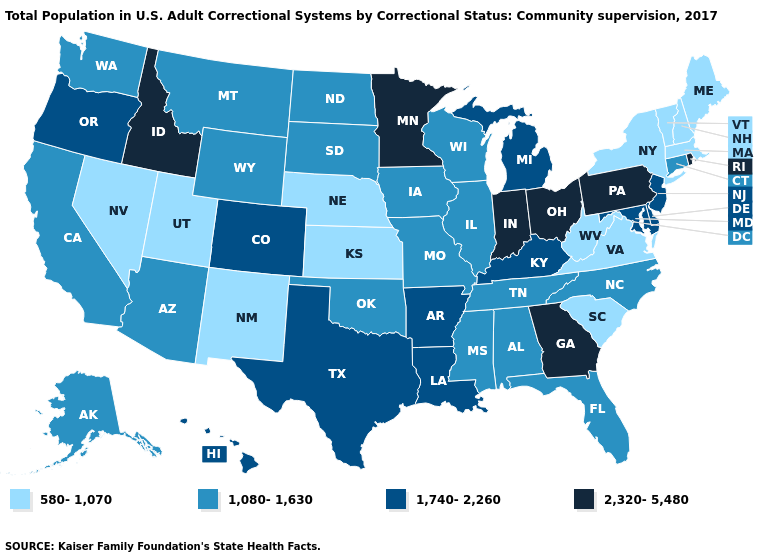Does the first symbol in the legend represent the smallest category?
Quick response, please. Yes. Among the states that border Kentucky , which have the highest value?
Quick response, please. Indiana, Ohio. What is the lowest value in states that border Kansas?
Write a very short answer. 580-1,070. Among the states that border Delaware , does Pennsylvania have the lowest value?
Be succinct. No. What is the highest value in the Northeast ?
Give a very brief answer. 2,320-5,480. Does Washington have a lower value than North Dakota?
Be succinct. No. What is the value of Illinois?
Answer briefly. 1,080-1,630. What is the value of Kansas?
Concise answer only. 580-1,070. Name the states that have a value in the range 1,080-1,630?
Write a very short answer. Alabama, Alaska, Arizona, California, Connecticut, Florida, Illinois, Iowa, Mississippi, Missouri, Montana, North Carolina, North Dakota, Oklahoma, South Dakota, Tennessee, Washington, Wisconsin, Wyoming. What is the highest value in the USA?
Short answer required. 2,320-5,480. What is the value of Pennsylvania?
Quick response, please. 2,320-5,480. Does Idaho have the highest value in the USA?
Write a very short answer. Yes. Does North Carolina have the highest value in the South?
Give a very brief answer. No. What is the value of Rhode Island?
Write a very short answer. 2,320-5,480. Among the states that border Louisiana , does Mississippi have the highest value?
Answer briefly. No. 